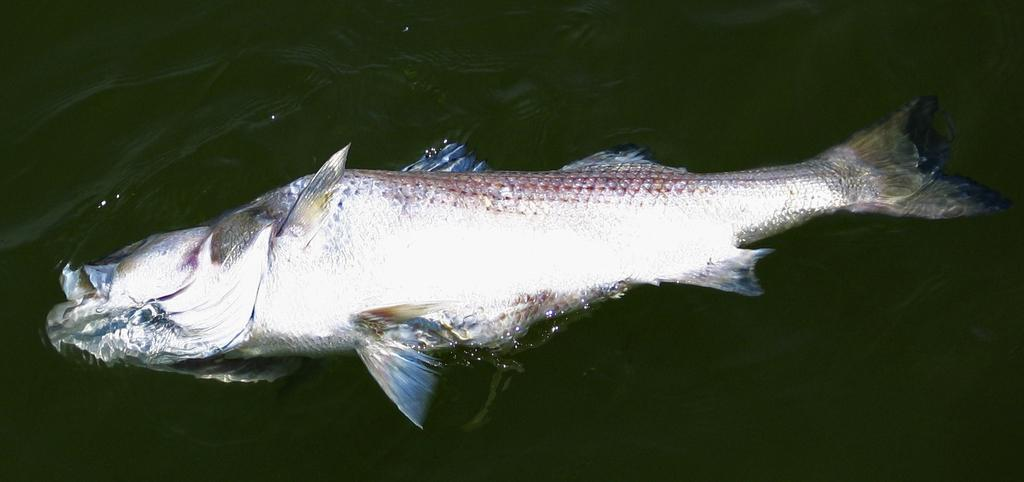What type of animals can be seen in the image? There are fish in the image. What type of cloth is being used to cover the fish in the image? There is no cloth present in the image, as it features fish and no such covering is visible. 